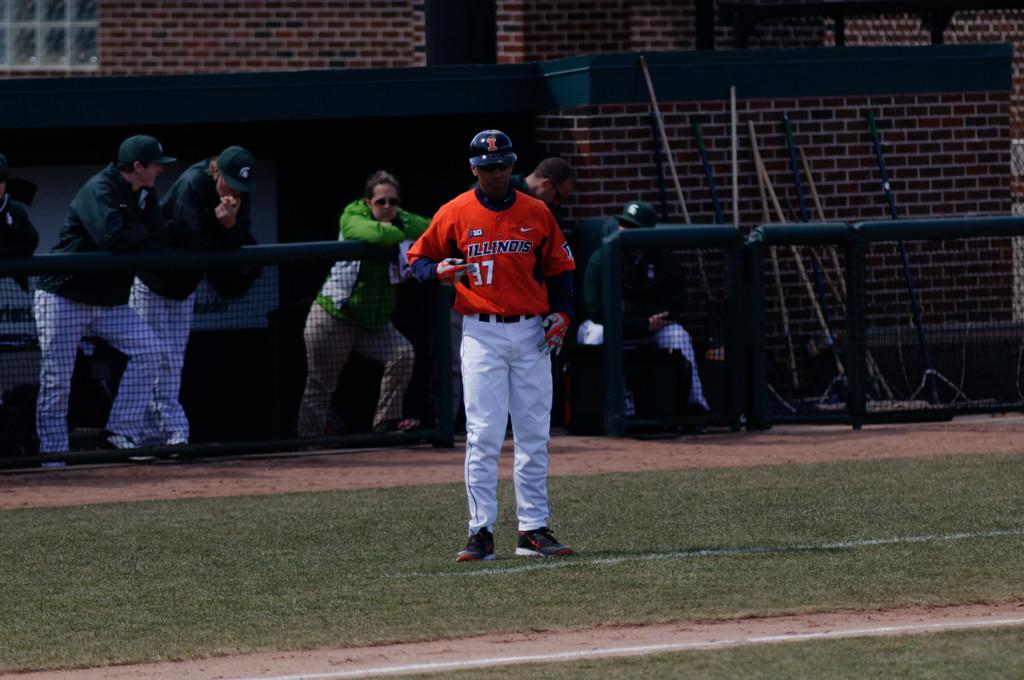<image>
Relay a brief, clear account of the picture shown. The baseball player on the field plays for Illinois. 